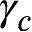Convert formula to latex. <formula><loc_0><loc_0><loc_500><loc_500>\gamma _ { c }</formula> 